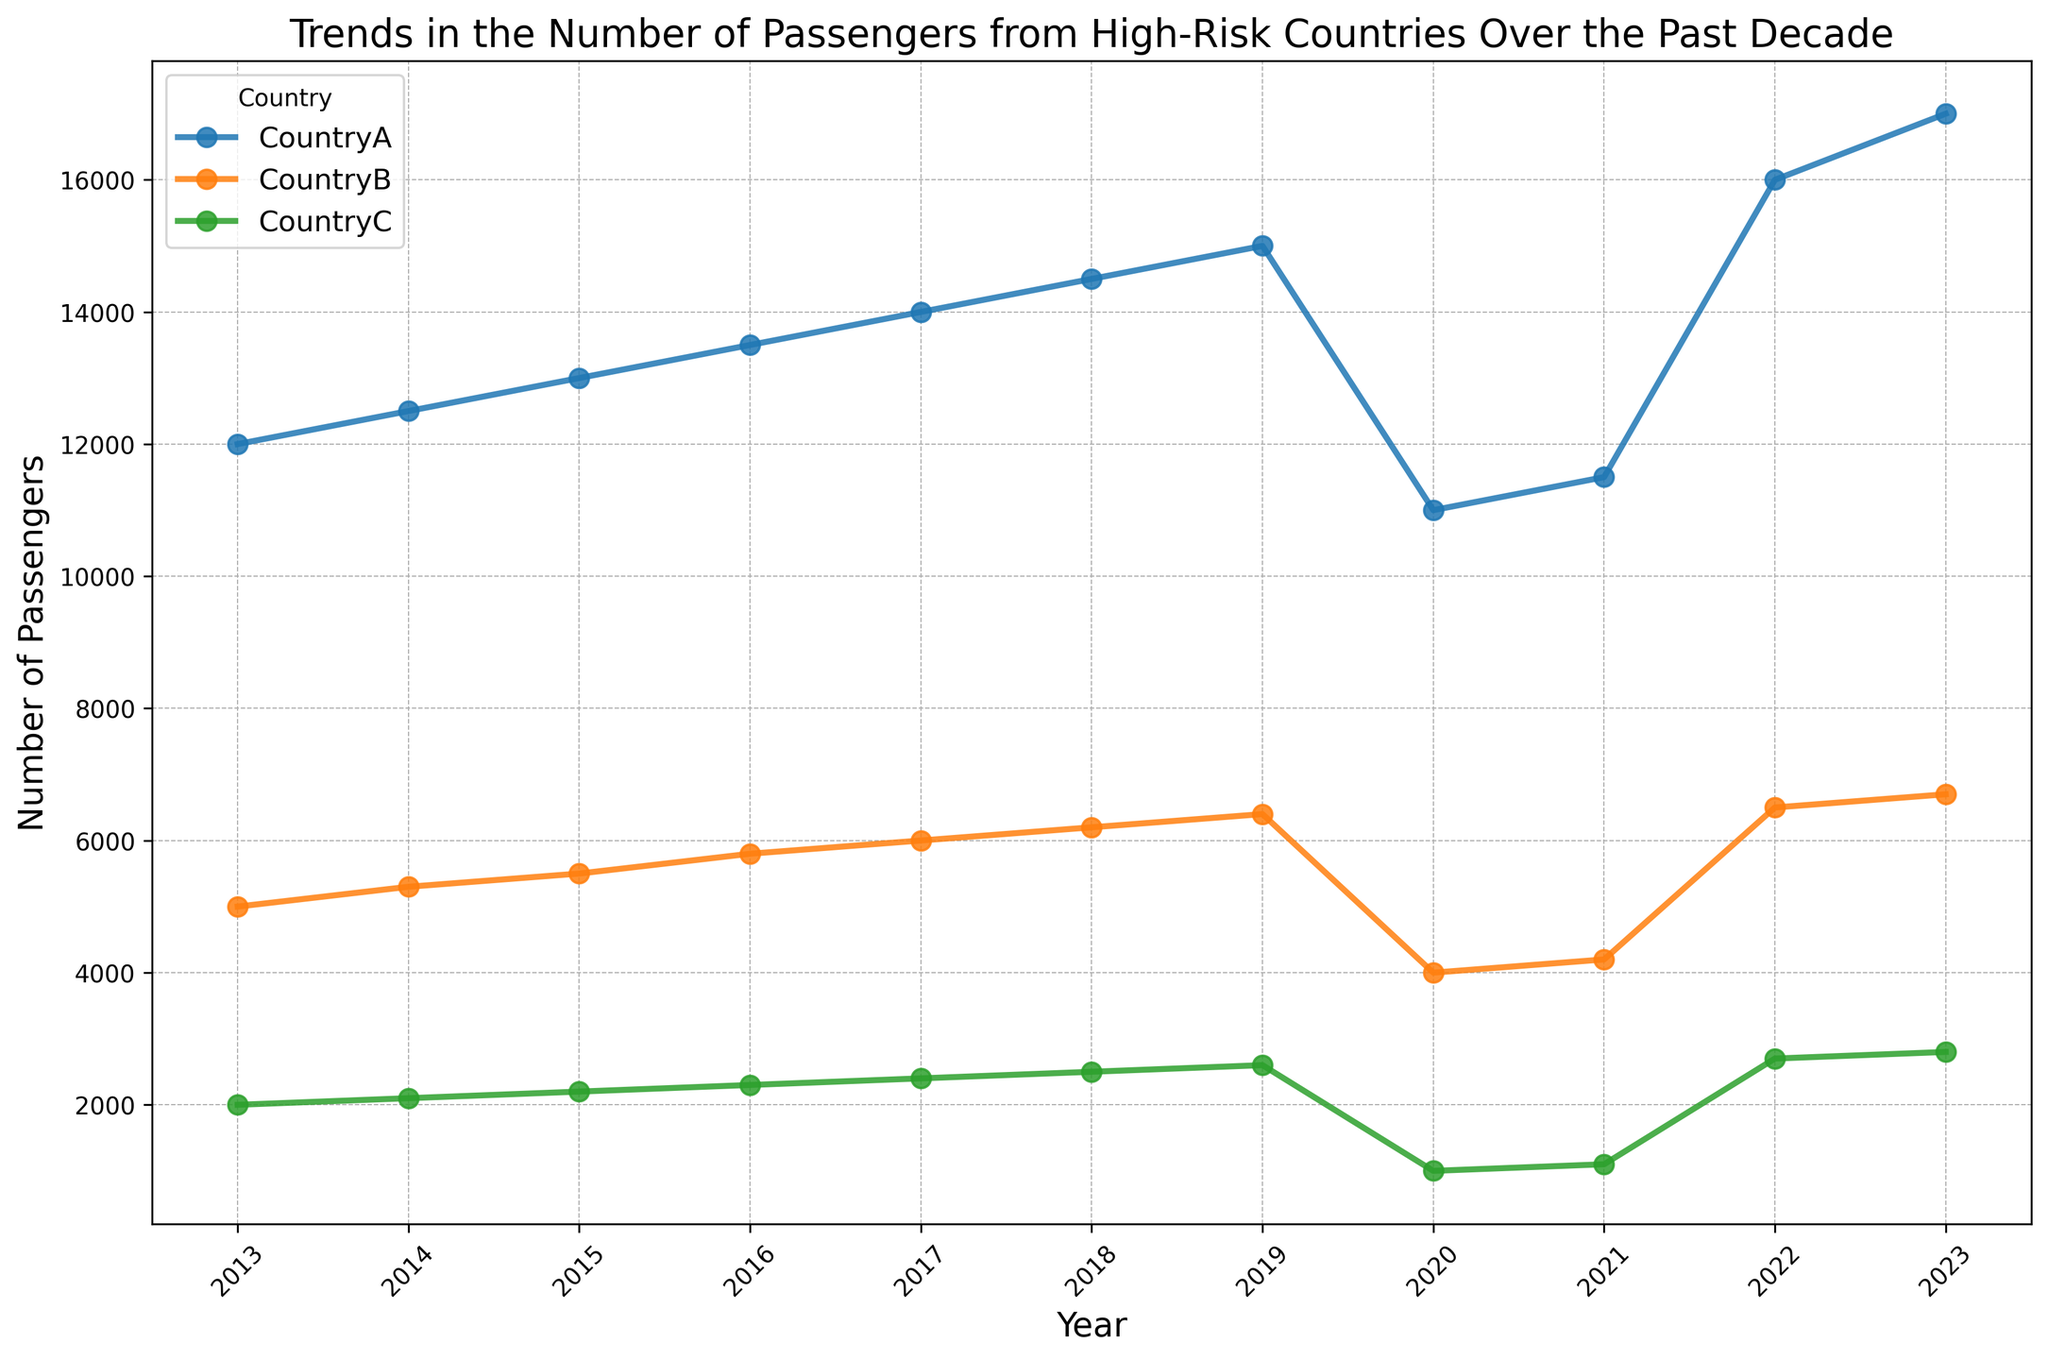what trend did Country A show from 2013 to 2023? From 2013 to 2019, the number of passengers from Country A showed a steady increase from 12,000 to 15,000. In 2020, there was a notable drop to 11,000, likely due to a specific event. From 2021 onwards, the numbers began to rise again, reaching 17,000 in 2023.
Answer: an increase with a dip in 2020 How do the passenger trends in Country B and Country C compare from 2018 to 2020? From 2018 to 2020, both countries experienced a drop in the number of passengers. Country B's passengers decreased from 6,200 in 2018 to 4,000 in 2020, and Country C's passengers declined from 2,500 to 1,000 in the same period.
Answer: both decreased What year did Country C have the lowest number of passengers? The lowest number of passengers for Country C was recorded in 2020, with a count of 1,000.
Answer: 2020 What is the overall pattern shown by Country A from 2020 to 2023? Country A's number of passengers showed an initial recovery from 2020 to 2021, slightly increasing from 11,000 to 11,500. Then, there was a sharp rise in passengers in 2022 and 2023, where the numbers jumped to 16,000 and 17,000 respectively.
Answer: steady increase In which year did Country B experience the highest number of passengers? The highest number of passengers for Country B was in 2023, with a total of 6,700.
Answer: 2023 What can you infer about the trends in passenger numbers for high-risk countries from 2019 to 2020? From 2019 to 2020, all three high-risk countries (A, B, and C) experienced a significant drop in passenger numbers. Country A decreased from 15,000 to 11,000, Country B from 6,400 to 4,000, and Country C from 2,600 to 1,000.
Answer: significant drop What is the combined number of passengers from all three countries in 2022? The combined number of passengers in 2022 is the sum of passengers from Country A (16,000), Country B (6,500), and Country C (2,700). Adding these gives a total of 16,000 + 6,500 + 2,700 = 25,200.
Answer: 25,200 Between 2013 and 2023, which country had the most stable trend in the number of passengers? Country C had the most stable trend from 2013 to 2019, with a gradual increase in passengers each year. Although there was a dip in 2020, the overall trend remained quite consistent compared to Countries A and B.
Answer: Country C 